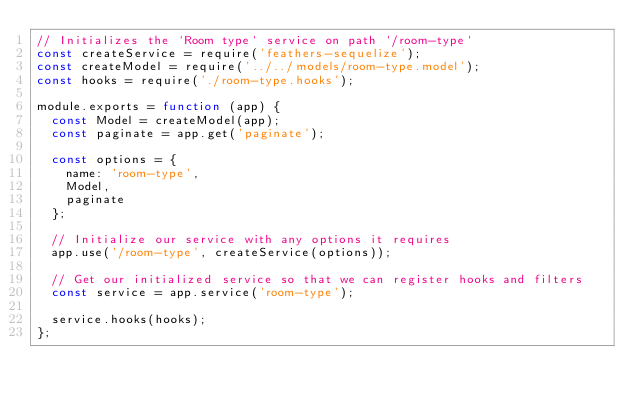Convert code to text. <code><loc_0><loc_0><loc_500><loc_500><_JavaScript_>// Initializes the `Room type` service on path `/room-type`
const createService = require('feathers-sequelize');
const createModel = require('../../models/room-type.model');
const hooks = require('./room-type.hooks');

module.exports = function (app) {
  const Model = createModel(app);
  const paginate = app.get('paginate');

  const options = {
    name: 'room-type',
    Model,
    paginate
  };

  // Initialize our service with any options it requires
  app.use('/room-type', createService(options));

  // Get our initialized service so that we can register hooks and filters
  const service = app.service('room-type');

  service.hooks(hooks);
};
</code> 